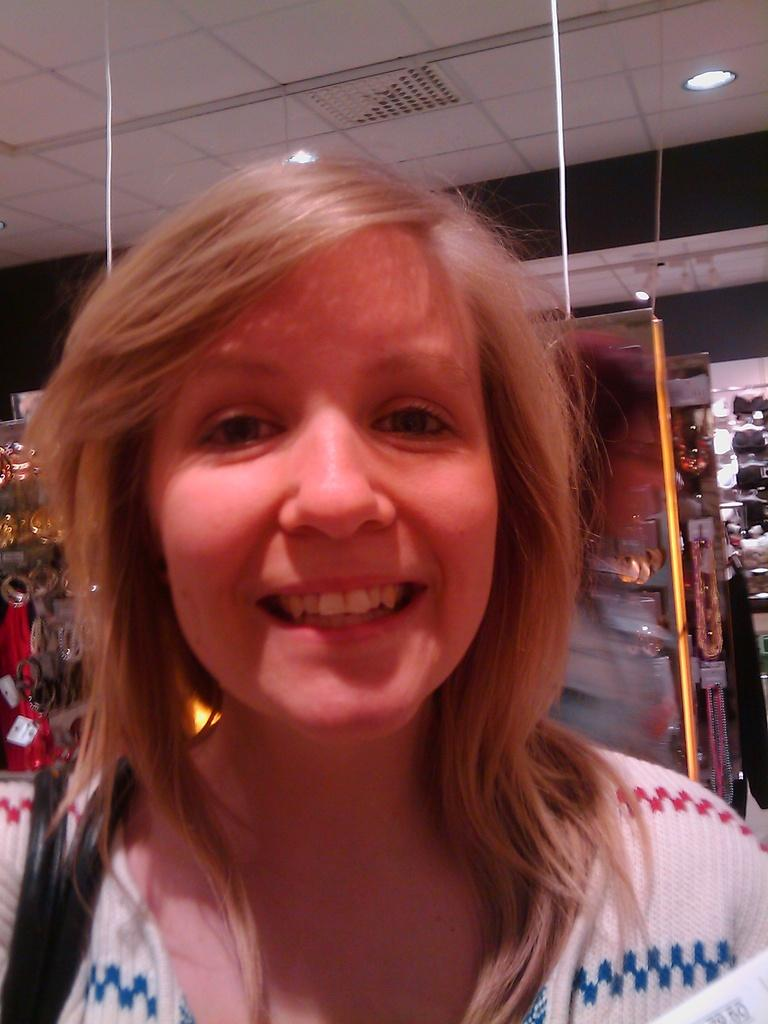What is the primary subject in the image? There is a woman in the image. What is the woman's facial expression? The woman is smiling. Can you describe the objects behind the woman? Unfortunately, the provided facts do not give enough information to describe the objects behind the woman. What type of nest can be seen in the woman's hair in the image? There is no nest present in the image, as the woman's hair is not mentioned in the provided facts. 